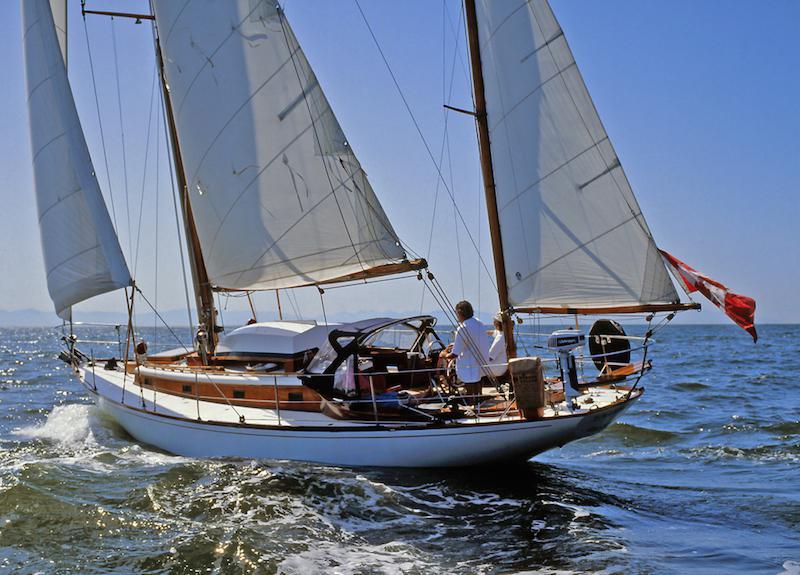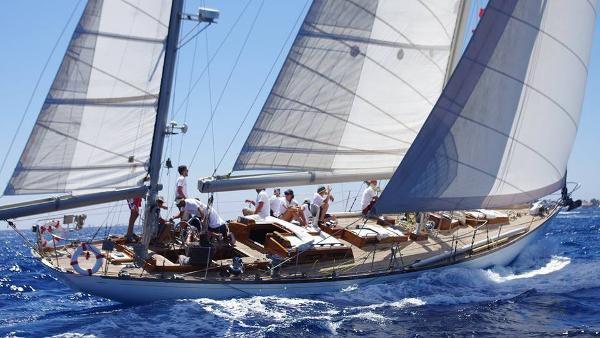The first image is the image on the left, the second image is the image on the right. For the images shown, is this caption "One of the sailboats is blue." true? Answer yes or no. No. The first image is the image on the left, the second image is the image on the right. Given the left and right images, does the statement "One sailboat has its sails furled and the other has sails unfurled." hold true? Answer yes or no. No. 